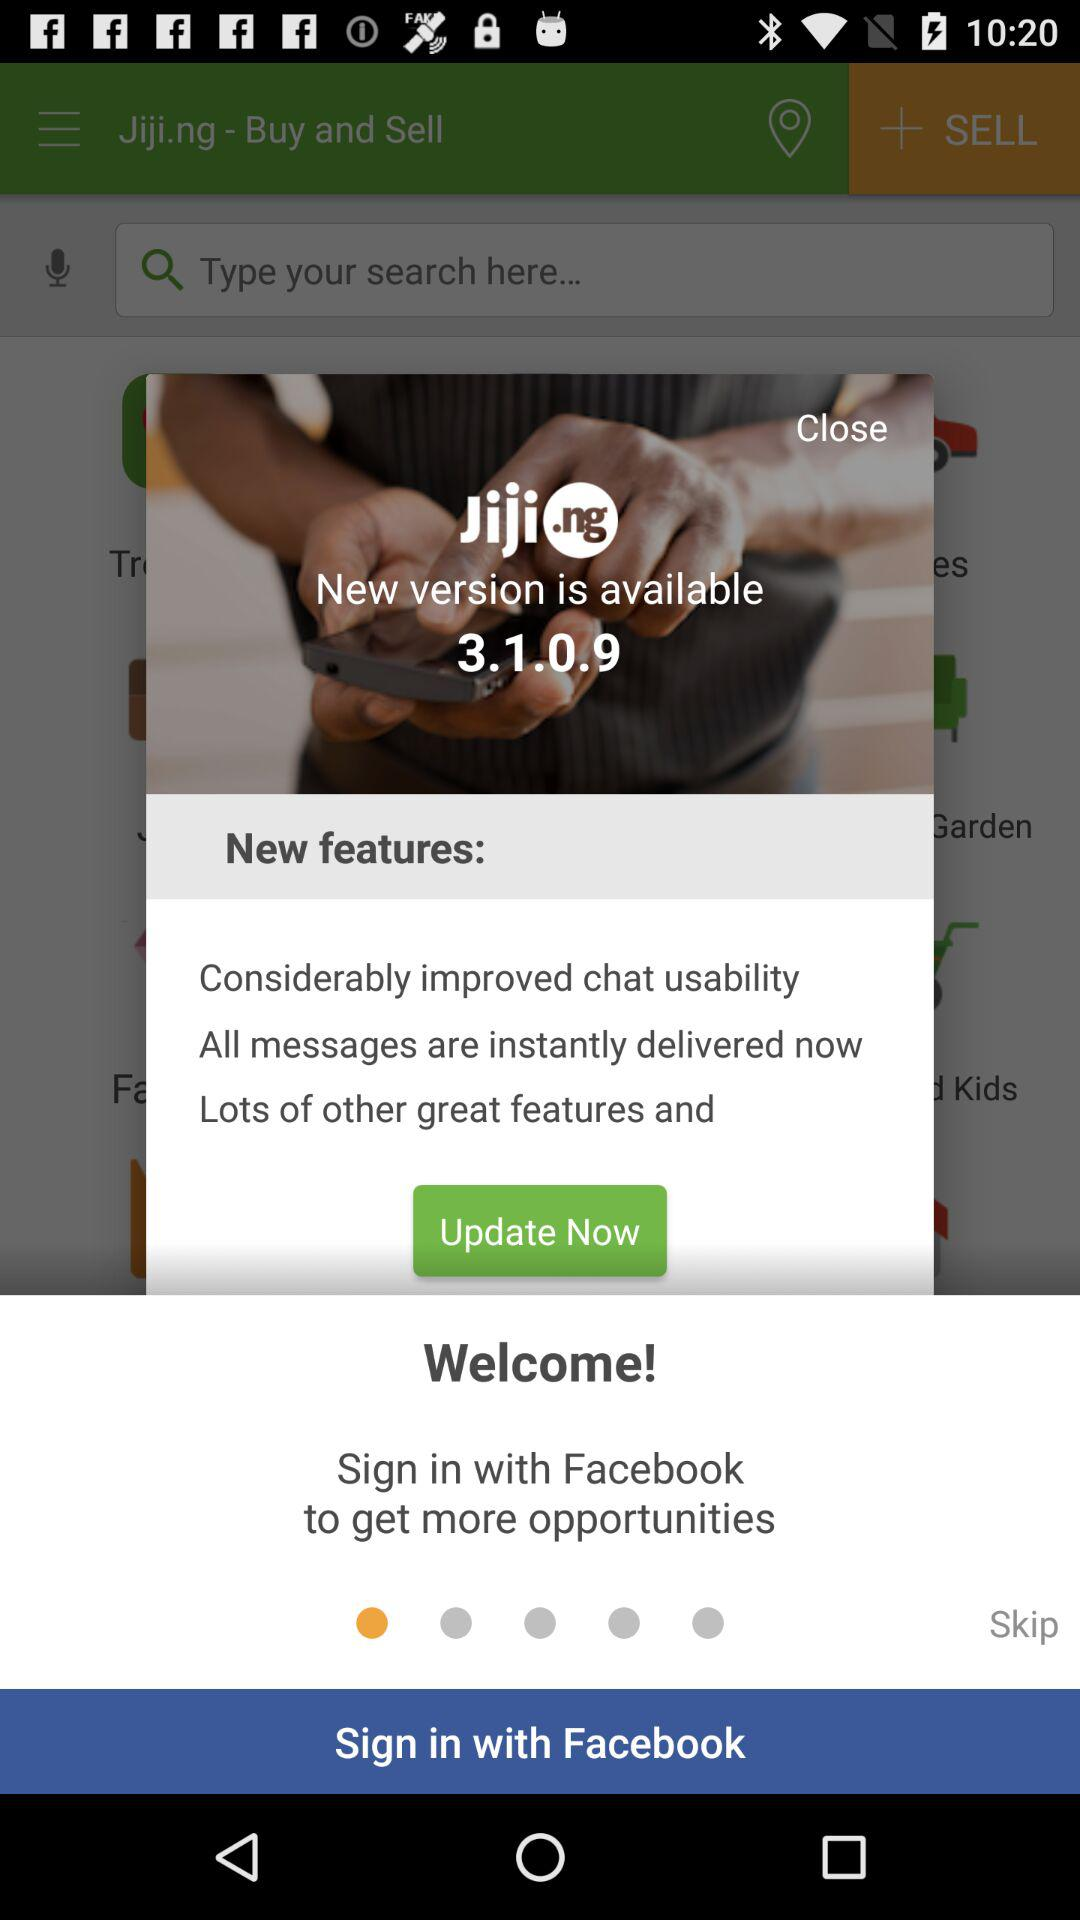What is the name of the application? The name of the application is "Jiji.ng - Buy and Sell". 